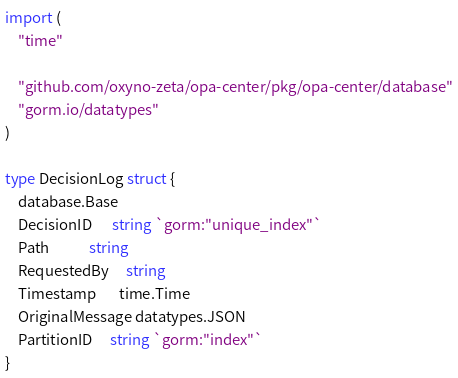Convert code to text. <code><loc_0><loc_0><loc_500><loc_500><_Go_>
import (
	"time"

	"github.com/oxyno-zeta/opa-center/pkg/opa-center/database"
	"gorm.io/datatypes"
)

type DecisionLog struct {
	database.Base
	DecisionID      string `gorm:"unique_index"`
	Path            string
	RequestedBy     string
	Timestamp       time.Time
	OriginalMessage datatypes.JSON
	PartitionID     string `gorm:"index"`
}
</code> 